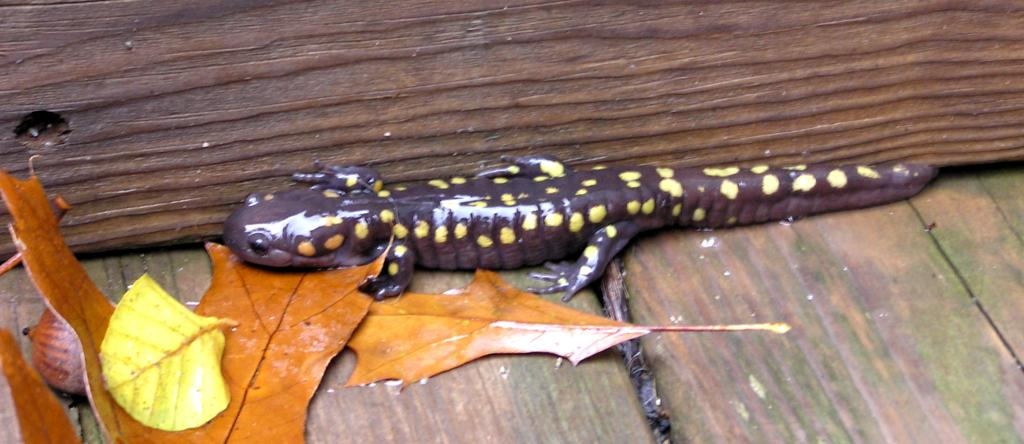What type of vegetation is on the left side of the image? There are leaves on the left side of the image. What animal can be seen in the middle of the image? There is a reptile in the middle of the image. What type of canvas is being used to paint the reptile in the image? There is no canvas or painting present in the image; it features a reptile in its natural environment. What type of holiday is being celebrated with the reptile in the image? There is no holiday depicted in the image; it simply shows a reptile in its natural environment. 